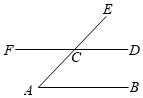What concept is illustrated by the angles and lines in this diagram? This diagram illustrates several fundamental concepts in geometry, including parallel lines, transversal lines, and corresponding angles. When a transversal, like AE, intersects parallel lines such as AB and CD, it creates several pairs of corresponding angles (e.g., angle A and angle ECD), which are equal. This allows us to derive relationships between unseen angles or verify the properties of the defined shapes and lines. 